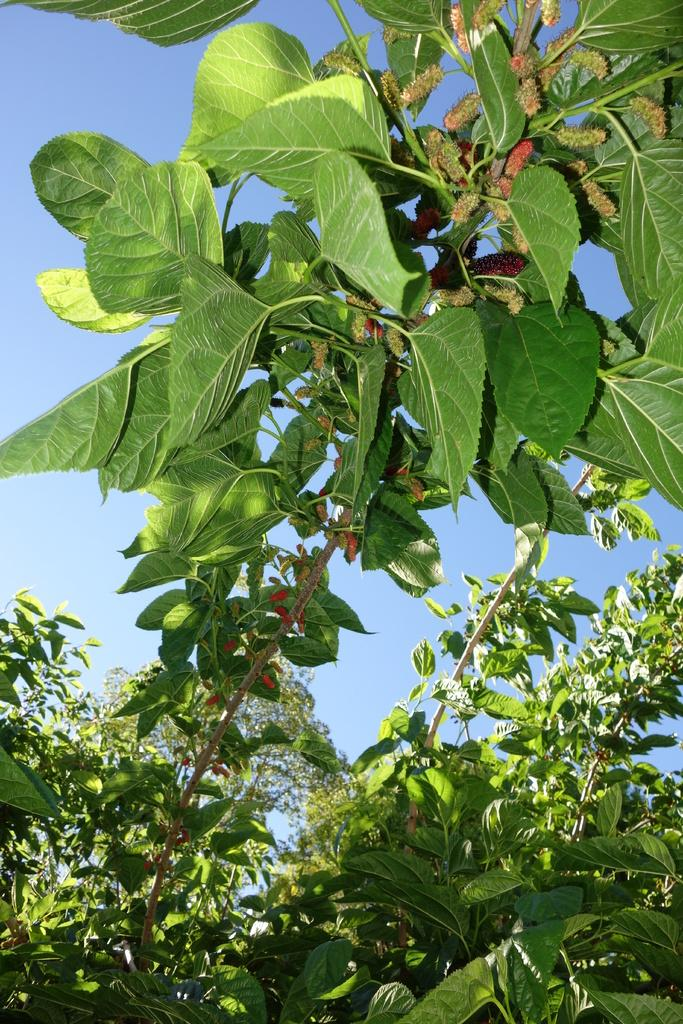What is the main subject of the image? The main subject of the image is a zoomed in picture of plants. Can you describe the background of the image? The sky is visible in the image. How many grapes can be seen hanging from the plants in the image? There are no grapes present in the image; it is a picture of plants. What type of heart is visible in the image? There is no heart present in the image; it is a picture of plants. 